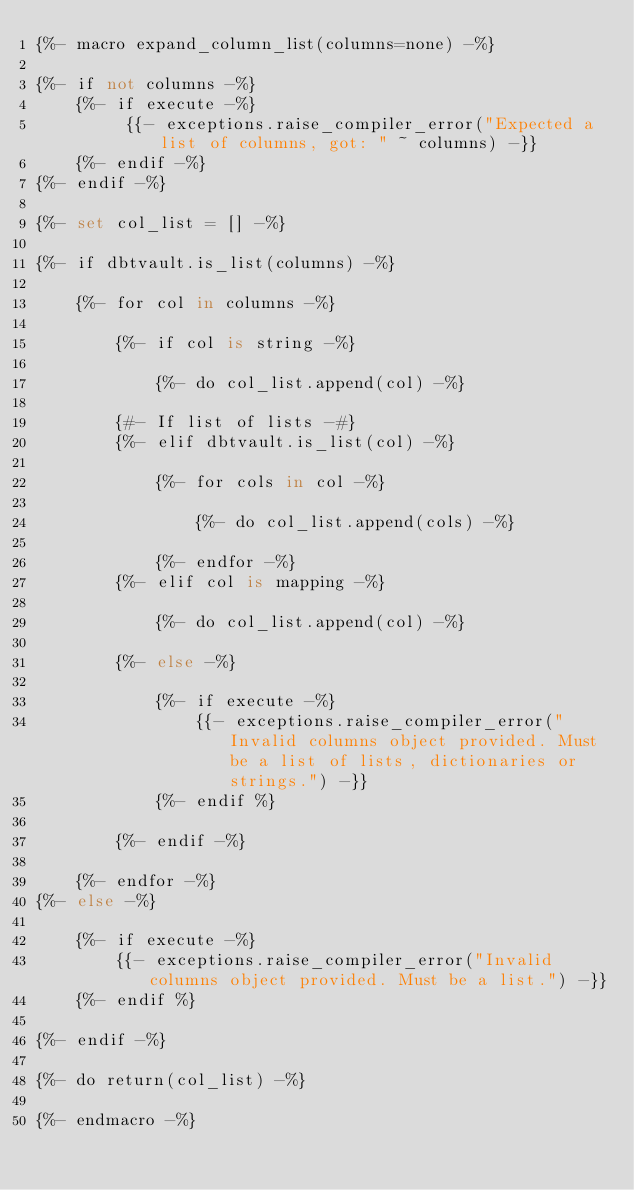Convert code to text. <code><loc_0><loc_0><loc_500><loc_500><_SQL_>{%- macro expand_column_list(columns=none) -%}

{%- if not columns -%}
    {%- if execute -%}
         {{- exceptions.raise_compiler_error("Expected a list of columns, got: " ~ columns) -}}
    {%- endif -%}
{%- endif -%}

{%- set col_list = [] -%}

{%- if dbtvault.is_list(columns) -%}

    {%- for col in columns -%}

        {%- if col is string -%}

            {%- do col_list.append(col) -%}

        {#- If list of lists -#}
        {%- elif dbtvault.is_list(col) -%}

            {%- for cols in col -%}

                {%- do col_list.append(cols) -%}

            {%- endfor -%}
        {%- elif col is mapping -%}

            {%- do col_list.append(col) -%}

        {%- else -%}

            {%- if execute -%}
                {{- exceptions.raise_compiler_error("Invalid columns object provided. Must be a list of lists, dictionaries or strings.") -}}
            {%- endif %}

        {%- endif -%}

    {%- endfor -%}
{%- else -%}

    {%- if execute -%}
        {{- exceptions.raise_compiler_error("Invalid columns object provided. Must be a list.") -}}
    {%- endif %}

{%- endif -%}

{%- do return(col_list) -%}

{%- endmacro -%}</code> 